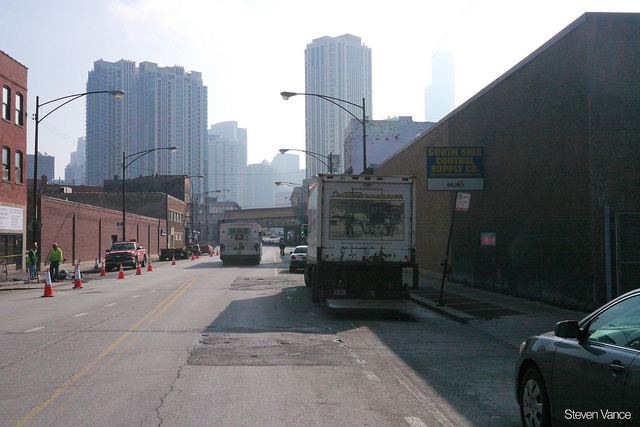Describe the objects in this image and their specific colors. I can see truck in lavender, black, gray, and purple tones, car in lavender, black, gray, and purple tones, bus in lavender, gray, black, and purple tones, truck in lavender, black, gray, and darkgray tones, and car in lavender, black, gray, darkgray, and blue tones in this image. 